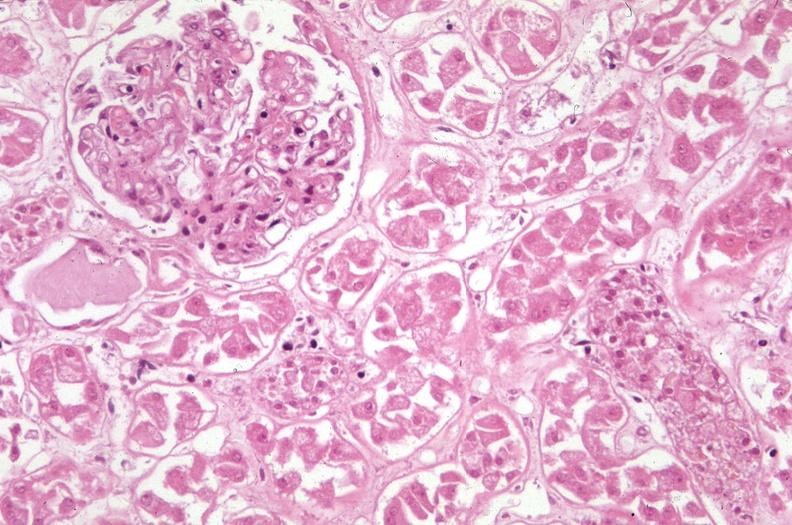why does this image show kidney, acute tubular necrosis?
Answer the question using a single word or phrase. Due to coagulopathy disseminated intravascular coagulation dic and shock alpha-1 antitrypsin deficiency 